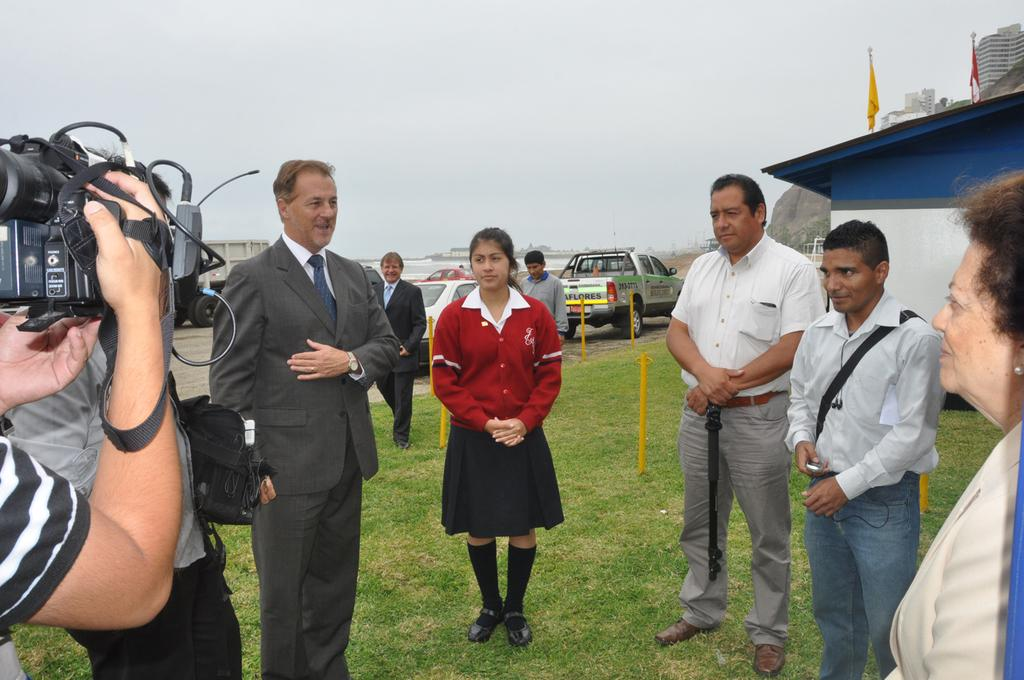What is the person in the image holding? The person is holding a camera. Can you describe the people in the image? There are people in the image, but their specific actions or characteristics are not mentioned in the facts. What is the landscape like in the image? The land is covered with grass. What can be seen in the background of the image? There are flags, buildings, and vehicles in the background. What type of quartz can be seen in the image? There is no quartz present in the image. Is there a market visible in the image? There is no mention of a market in the image. 